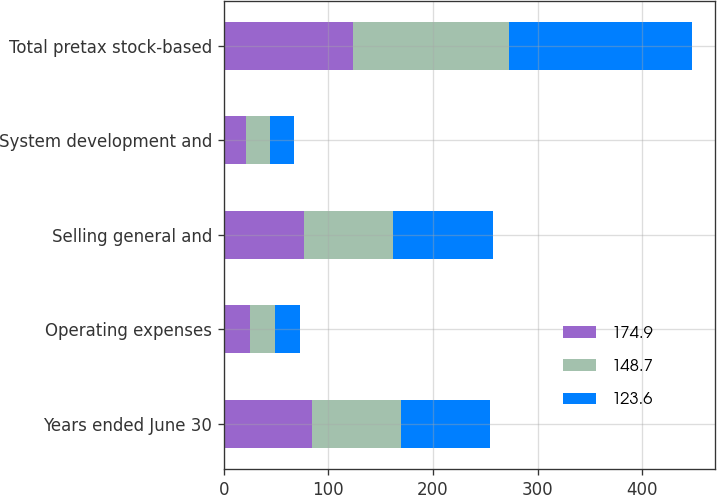Convert chart. <chart><loc_0><loc_0><loc_500><loc_500><stacked_bar_chart><ecel><fcel>Years ended June 30<fcel>Operating expenses<fcel>Selling general and<fcel>System development and<fcel>Total pretax stock-based<nl><fcel>174.9<fcel>84.7<fcel>25.4<fcel>76.7<fcel>21.5<fcel>123.6<nl><fcel>148.7<fcel>84.7<fcel>23.3<fcel>84.7<fcel>22.5<fcel>148.7<nl><fcel>123.6<fcel>84.7<fcel>23.7<fcel>95.7<fcel>23.3<fcel>174.9<nl></chart> 